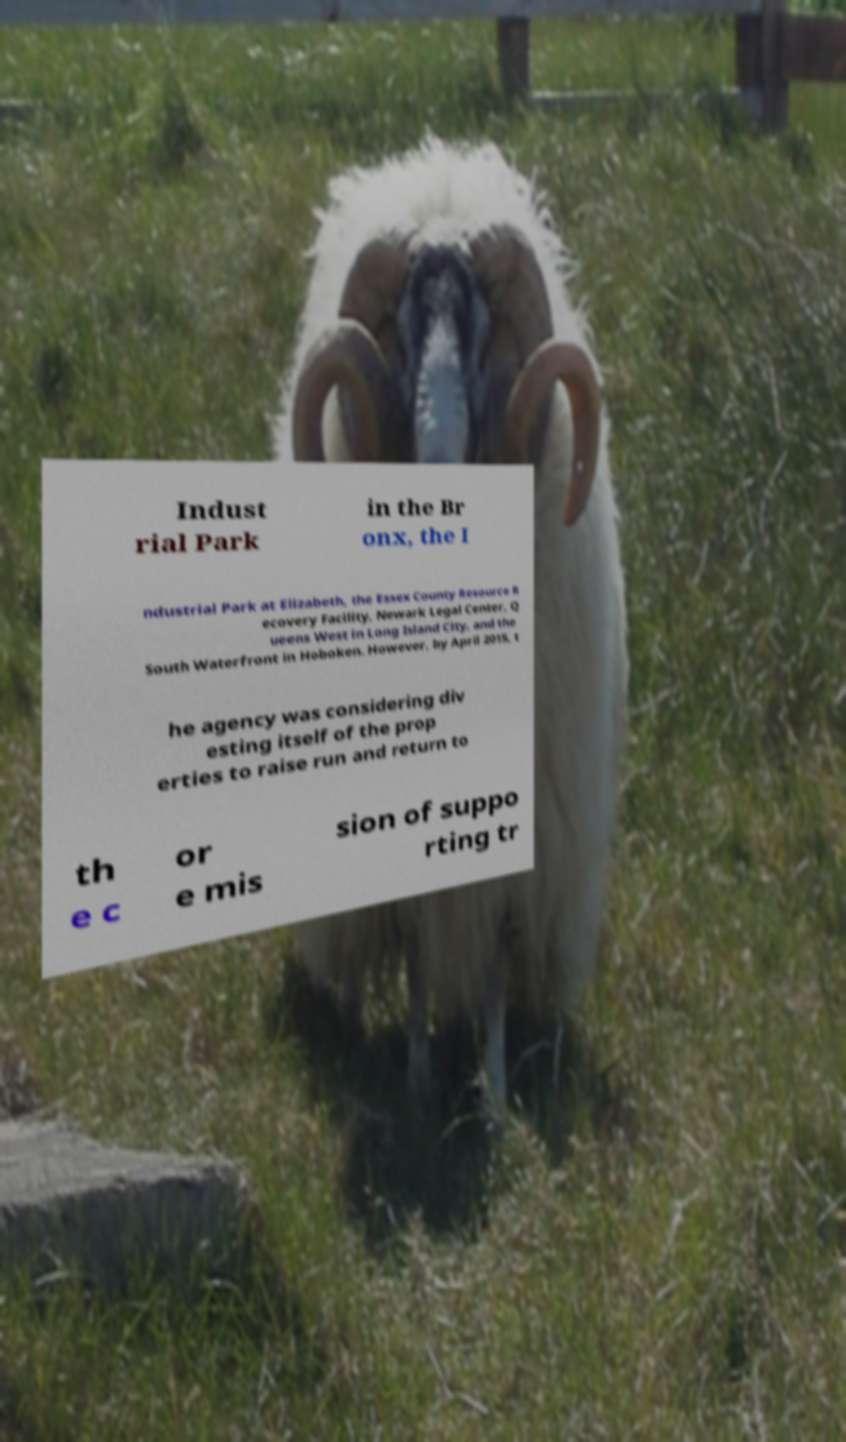Could you assist in decoding the text presented in this image and type it out clearly? Indust rial Park in the Br onx, the I ndustrial Park at Elizabeth, the Essex County Resource R ecovery Facility, Newark Legal Center, Q ueens West in Long Island City, and the South Waterfront in Hoboken. However, by April 2015, t he agency was considering div esting itself of the prop erties to raise run and return to th e c or e mis sion of suppo rting tr 